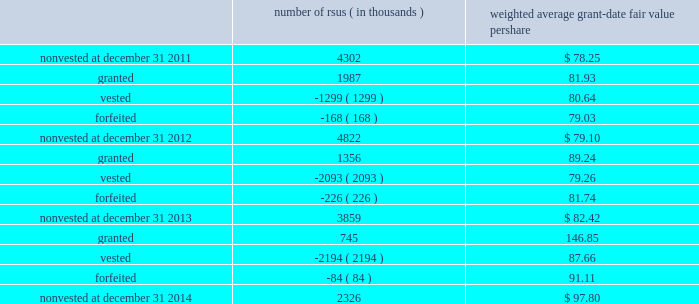Note 11 2013 stock-based compensation during 2014 , 2013 and 2012 , we recorded non-cash stock-based compensation expense totaling $ 164 million , $ 189 million and $ 167 million , which is included as a component of other unallocated , net on our statements of earnings .
The net impact to earnings for the respective years was $ 107 million , $ 122 million and $ 108 million .
As of december 31 , 2014 , we had $ 91 million of unrecognized compensation cost related to nonvested awards , which is expected to be recognized over a weighted average period of 1.6 years .
We received cash from the exercise of stock options totaling $ 308 million , $ 827 million and $ 440 million during 2014 , 2013 and 2012 .
In addition , our income tax liabilities for 2014 , 2013 and 2012 were reduced by $ 215 million , $ 158 million , $ 96 million due to recognized tax benefits on stock-based compensation arrangements .
Stock-based compensation plans under plans approved by our stockholders , we are authorized to grant key employees stock-based incentive awards , including options to purchase common stock , stock appreciation rights , restricted stock units ( rsus ) , performance stock units ( psus ) or other stock units .
The exercise price of options to purchase common stock may not be less than the fair market value of our stock on the date of grant .
No award of stock options may become fully vested prior to the third anniversary of the grant and no portion of a stock option grant may become vested in less than one year .
The minimum vesting period for restricted stock or stock units payable in stock is three years .
Award agreements may provide for shorter or pro-rated vesting periods or vesting following termination of employment in the case of death , disability , divestiture , retirement , change of control or layoff .
The maximum term of a stock option or any other award is 10 years .
At december 31 , 2014 , inclusive of the shares reserved for outstanding stock options , rsus and psus , we had 19 million shares reserved for issuance under the plans .
At december 31 , 2014 , 7.8 million of the shares reserved for issuance remained available for grant under our stock-based compensation plans .
We issue new shares upon the exercise of stock options or when restrictions on rsus and psus have been satisfied .
The table summarizes activity related to nonvested rsus during 2014 : number of rsus ( in thousands ) weighted average grant-date fair value per share .
Rsus are valued based on the fair value of our common stock on the date of grant .
Employees who are granted rsus receive the right to receive shares of stock after completion of the vesting period ; however , the shares are not issued and the employees cannot sell or transfer shares prior to vesting and have no voting rights until the rsus vest , generally three years from the date of the award .
Employees who are granted rsus receive dividend-equivalent cash payments only upon vesting .
For these rsu awards , the grant-date fair value is equal to the closing market price of our common stock on the date of grant less a discount to reflect the delay in payment of dividend-equivalent cash payments .
We recognize the grant-date fair value of rsus , less estimated forfeitures , as compensation expense ratably over the requisite service period , which beginning with the rsus granted in 2013 is shorter than the vesting period if the employee is retirement eligible on the date of grant or will become retirement eligible before the end of the vesting period. .
What was the percentage change in non-cash stock-based compensation expense from 2013 to 2014? 
Computations: ((164 - 189) / 189)
Answer: -0.13228. 